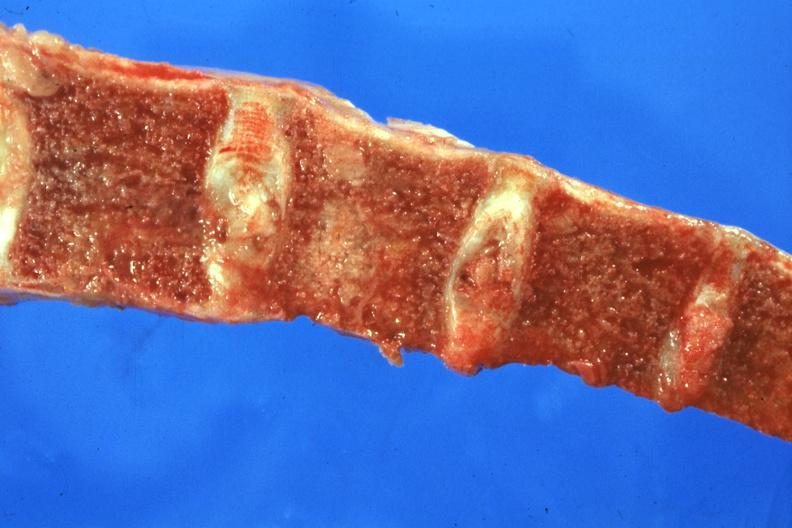does this image show sectioned bone with two nodules of tumor?
Answer the question using a single word or phrase. Yes 